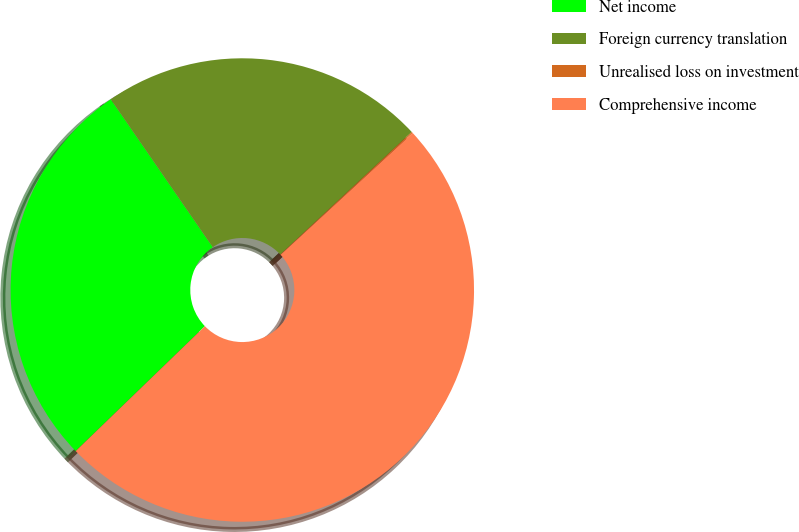<chart> <loc_0><loc_0><loc_500><loc_500><pie_chart><fcel>Net income<fcel>Foreign currency translation<fcel>Unrealised loss on investment<fcel>Comprehensive income<nl><fcel>27.62%<fcel>22.66%<fcel>0.09%<fcel>49.62%<nl></chart> 